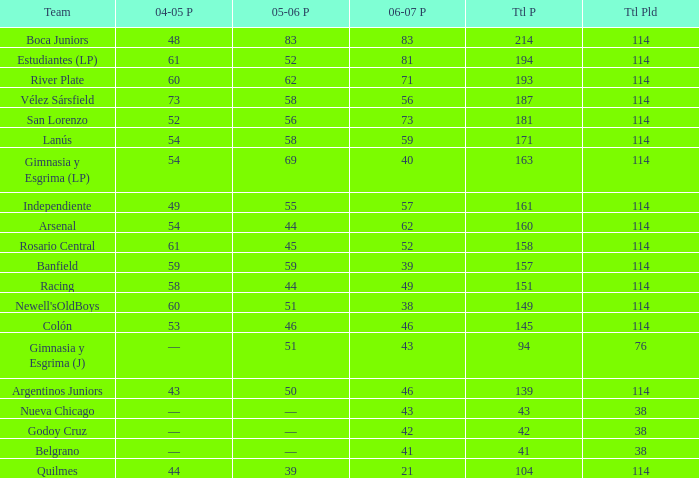What is the total number of PLD for Team Arsenal? 1.0. 